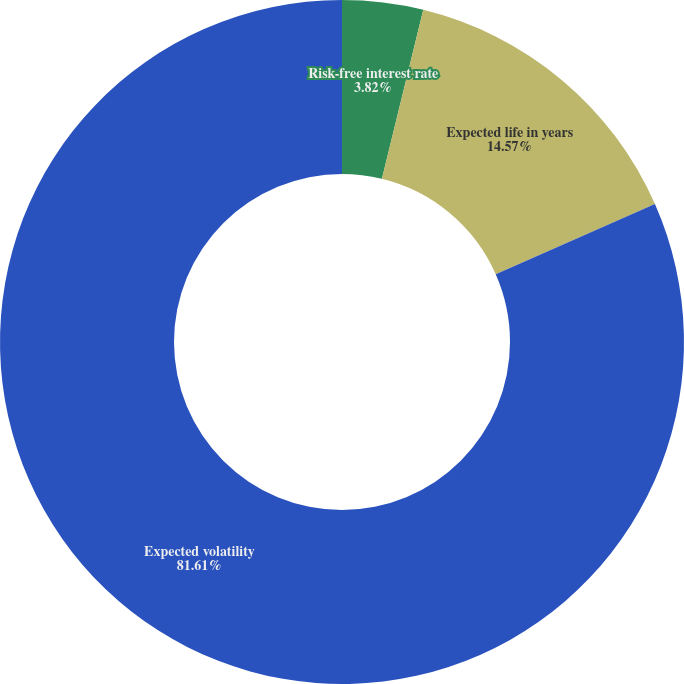Convert chart to OTSL. <chart><loc_0><loc_0><loc_500><loc_500><pie_chart><fcel>Risk-free interest rate<fcel>Expected life in years<fcel>Expected volatility<nl><fcel>3.82%<fcel>14.57%<fcel>81.61%<nl></chart> 